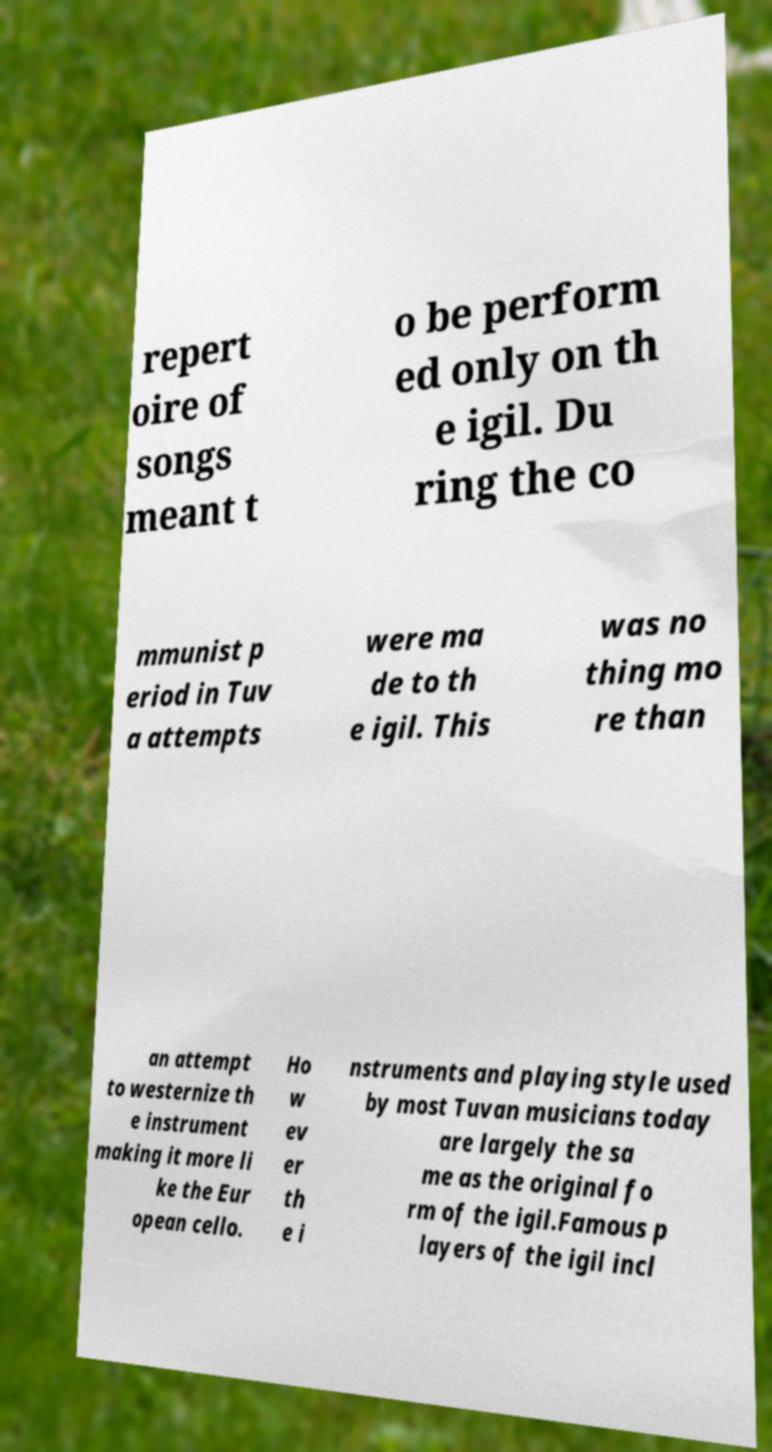Could you extract and type out the text from this image? repert oire of songs meant t o be perform ed only on th e igil. Du ring the co mmunist p eriod in Tuv a attempts were ma de to th e igil. This was no thing mo re than an attempt to westernize th e instrument making it more li ke the Eur opean cello. Ho w ev er th e i nstruments and playing style used by most Tuvan musicians today are largely the sa me as the original fo rm of the igil.Famous p layers of the igil incl 